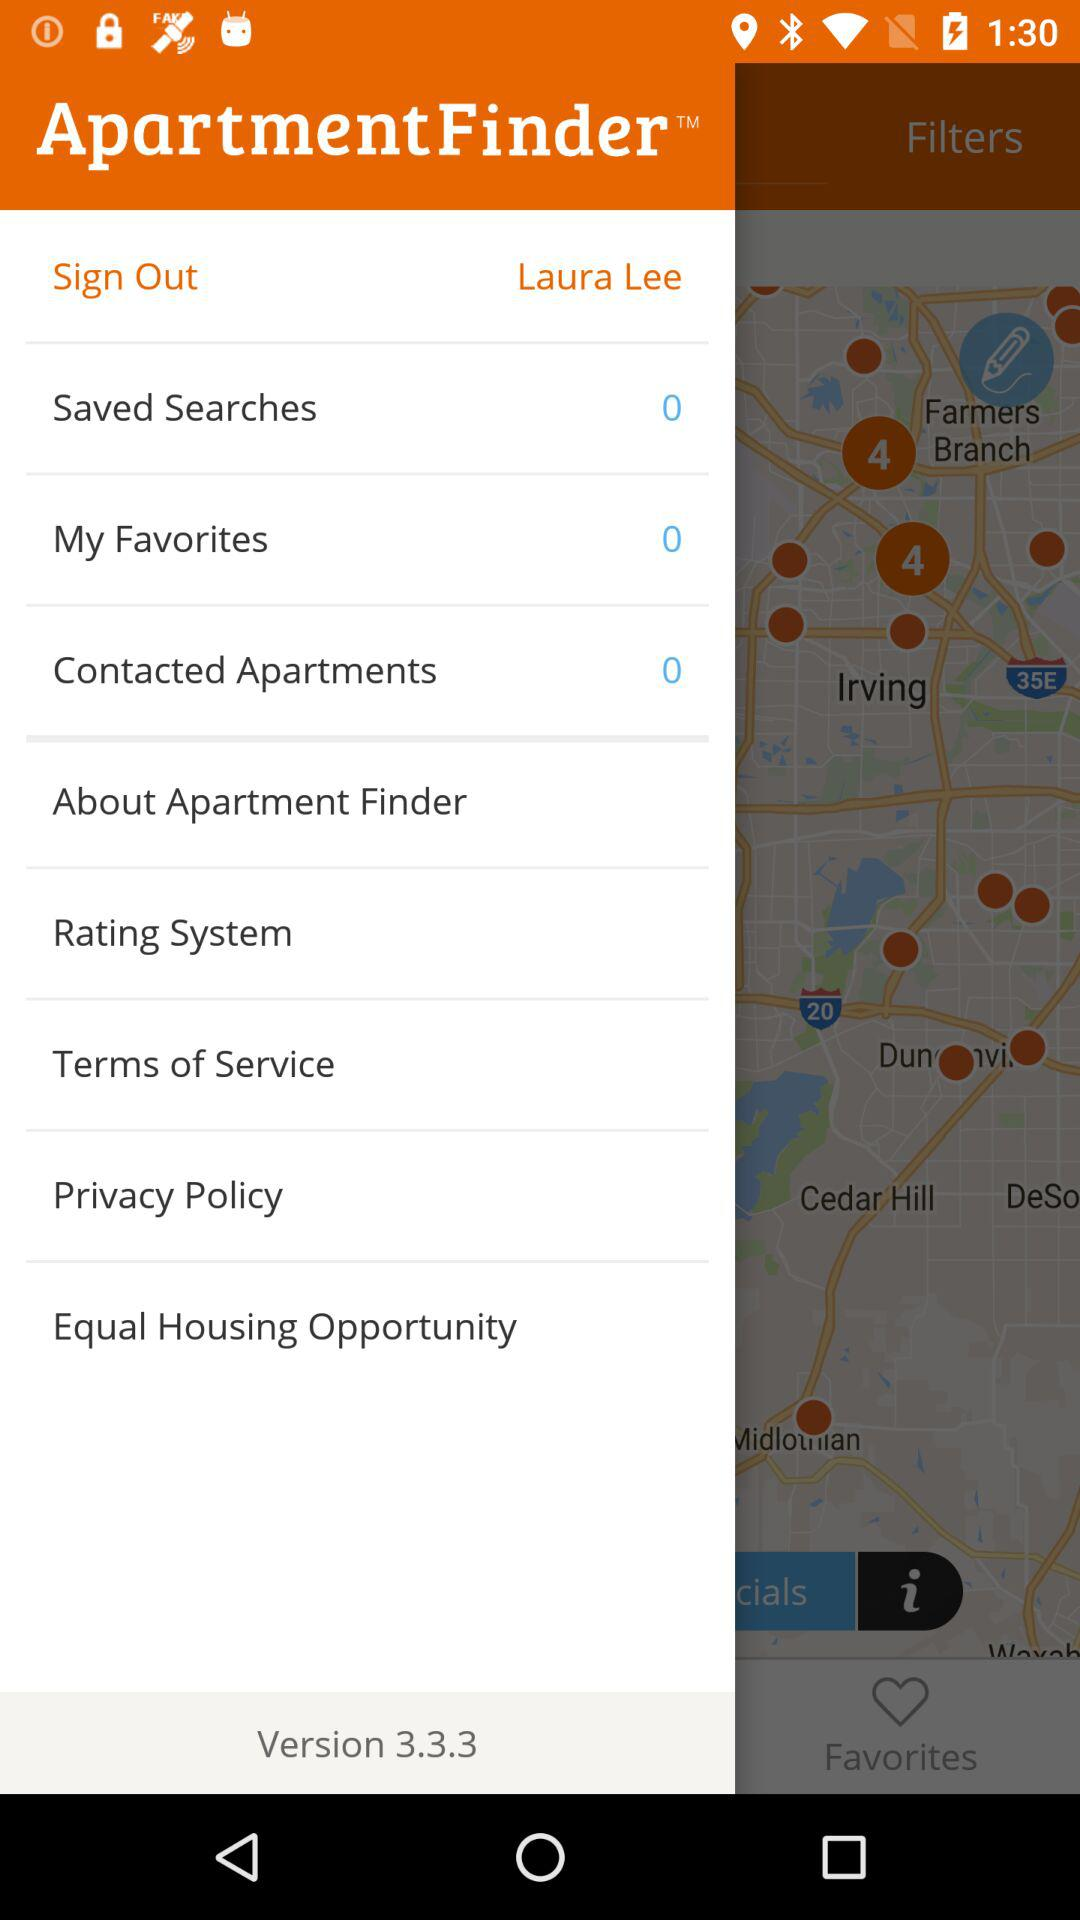What is the total number of "My Favorites"? The total number of "My Favorites" is 0. 